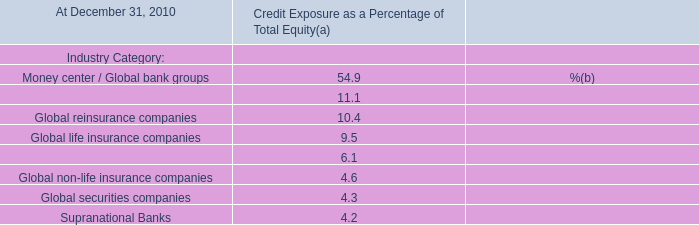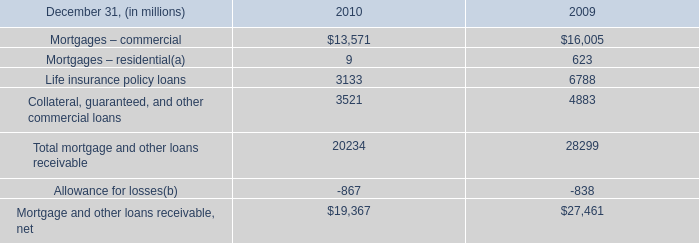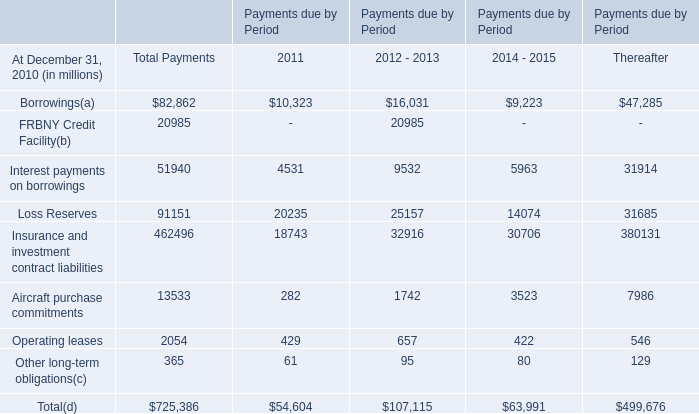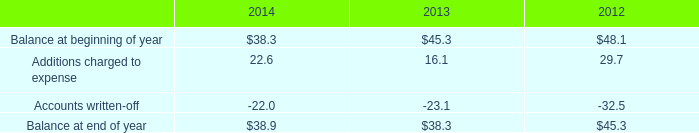What's the sum of Mortgage and other loans receivable, net of 2010, and Borrowings of Payments due by Period 2011 ? 
Computations: (19367.0 + 10323.0)
Answer: 29690.0. 